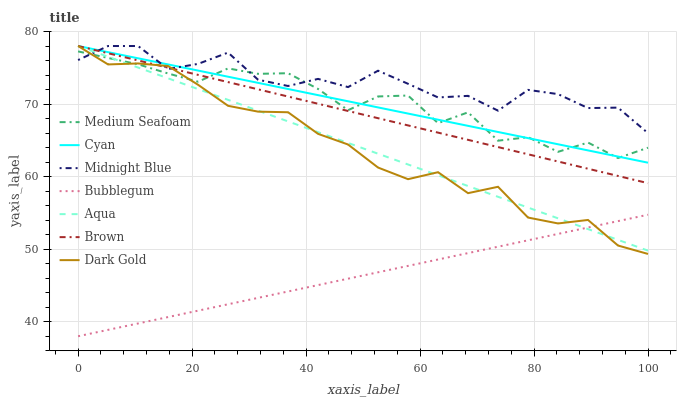Does Bubblegum have the minimum area under the curve?
Answer yes or no. Yes. Does Midnight Blue have the maximum area under the curve?
Answer yes or no. Yes. Does Dark Gold have the minimum area under the curve?
Answer yes or no. No. Does Dark Gold have the maximum area under the curve?
Answer yes or no. No. Is Bubblegum the smoothest?
Answer yes or no. Yes. Is Midnight Blue the roughest?
Answer yes or no. Yes. Is Dark Gold the smoothest?
Answer yes or no. No. Is Dark Gold the roughest?
Answer yes or no. No. Does Bubblegum have the lowest value?
Answer yes or no. Yes. Does Dark Gold have the lowest value?
Answer yes or no. No. Does Cyan have the highest value?
Answer yes or no. Yes. Does Bubblegum have the highest value?
Answer yes or no. No. Is Bubblegum less than Cyan?
Answer yes or no. Yes. Is Brown greater than Bubblegum?
Answer yes or no. Yes. Does Midnight Blue intersect Aqua?
Answer yes or no. Yes. Is Midnight Blue less than Aqua?
Answer yes or no. No. Is Midnight Blue greater than Aqua?
Answer yes or no. No. Does Bubblegum intersect Cyan?
Answer yes or no. No. 